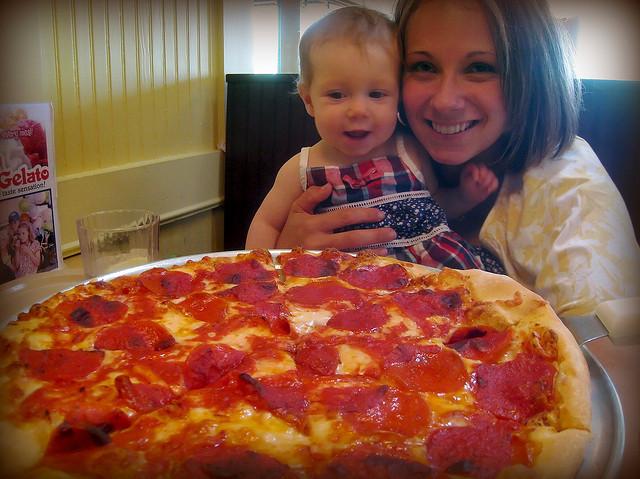Is this a large size pizza?
Keep it brief. Yes. Is this girl hungry?
Quick response, please. Yes. Who many people can eat this pizza?
Answer briefly. 4. How many stove knobs are visible?
Answer briefly. 0. What is the person doing?
Short answer required. Smiling. Is this a man or a woman?
Keep it brief. Woman. What is the red word on the sign by the wall?
Keep it brief. Gelato. Is the woman wearing jewelry?
Quick response, please. No. What type of mood is the woman in?
Be succinct. Happy. How many pizza types are there?
Answer briefly. 1. What is the topping on the pizza?
Write a very short answer. Pepperoni. What is the person holding?
Quick response, please. Baby. What does the woman have hanging from her neck?
Give a very brief answer. Necklace. What is the baby looking at?
Write a very short answer. Pizza. What toppings are on the pizza?
Short answer required. Pepperoni. What are the toppings on the pizza?
Write a very short answer. Pepperoni. 